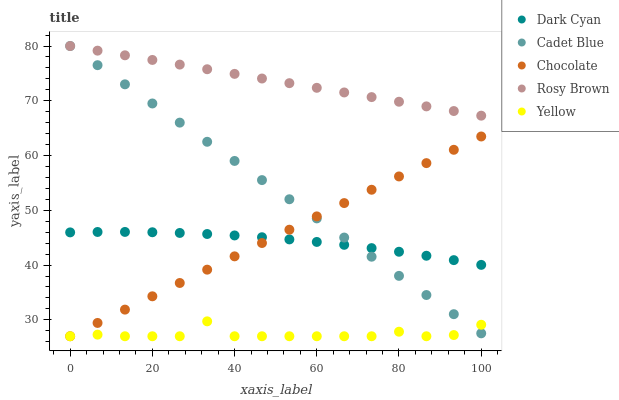Does Yellow have the minimum area under the curve?
Answer yes or no. Yes. Does Rosy Brown have the maximum area under the curve?
Answer yes or no. Yes. Does Cadet Blue have the minimum area under the curve?
Answer yes or no. No. Does Cadet Blue have the maximum area under the curve?
Answer yes or no. No. Is Chocolate the smoothest?
Answer yes or no. Yes. Is Yellow the roughest?
Answer yes or no. Yes. Is Rosy Brown the smoothest?
Answer yes or no. No. Is Rosy Brown the roughest?
Answer yes or no. No. Does Yellow have the lowest value?
Answer yes or no. Yes. Does Cadet Blue have the lowest value?
Answer yes or no. No. Does Cadet Blue have the highest value?
Answer yes or no. Yes. Does Yellow have the highest value?
Answer yes or no. No. Is Chocolate less than Rosy Brown?
Answer yes or no. Yes. Is Rosy Brown greater than Chocolate?
Answer yes or no. Yes. Does Dark Cyan intersect Cadet Blue?
Answer yes or no. Yes. Is Dark Cyan less than Cadet Blue?
Answer yes or no. No. Is Dark Cyan greater than Cadet Blue?
Answer yes or no. No. Does Chocolate intersect Rosy Brown?
Answer yes or no. No. 